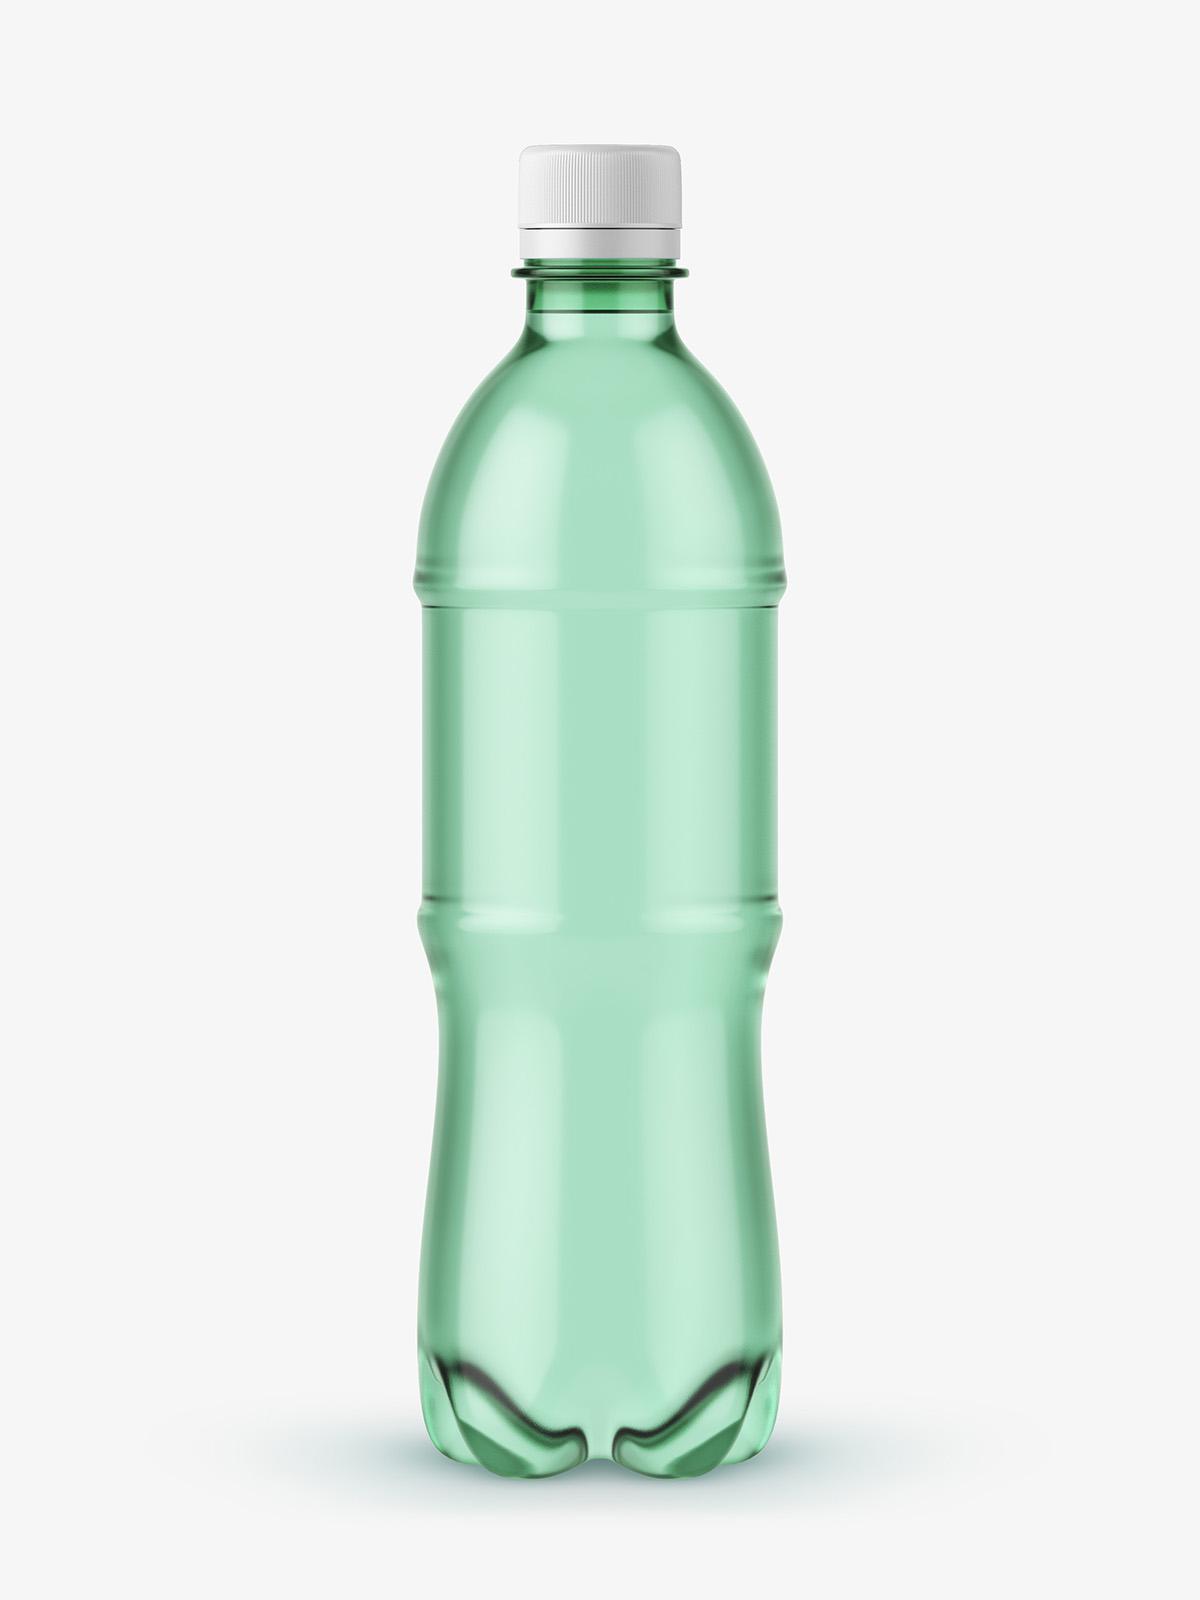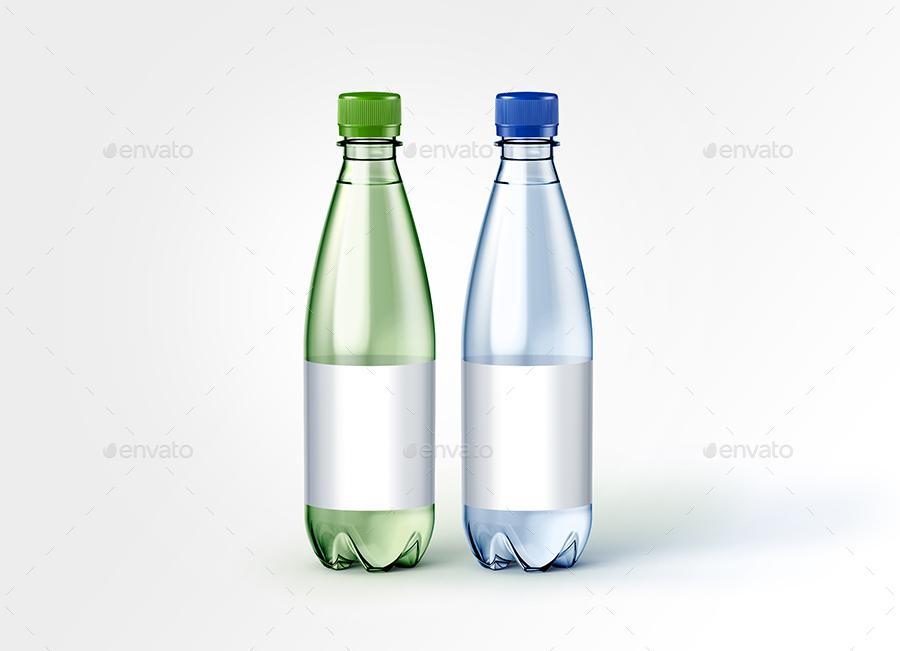The first image is the image on the left, the second image is the image on the right. Assess this claim about the two images: "The left image contains no more than one bottle.". Correct or not? Answer yes or no. Yes. The first image is the image on the left, the second image is the image on the right. Analyze the images presented: Is the assertion "Three bottles are grouped together in the image on the left." valid? Answer yes or no. No. 